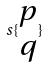<formula> <loc_0><loc_0><loc_500><loc_500>s \{ \begin{matrix} p \\ q \end{matrix} \}</formula> 